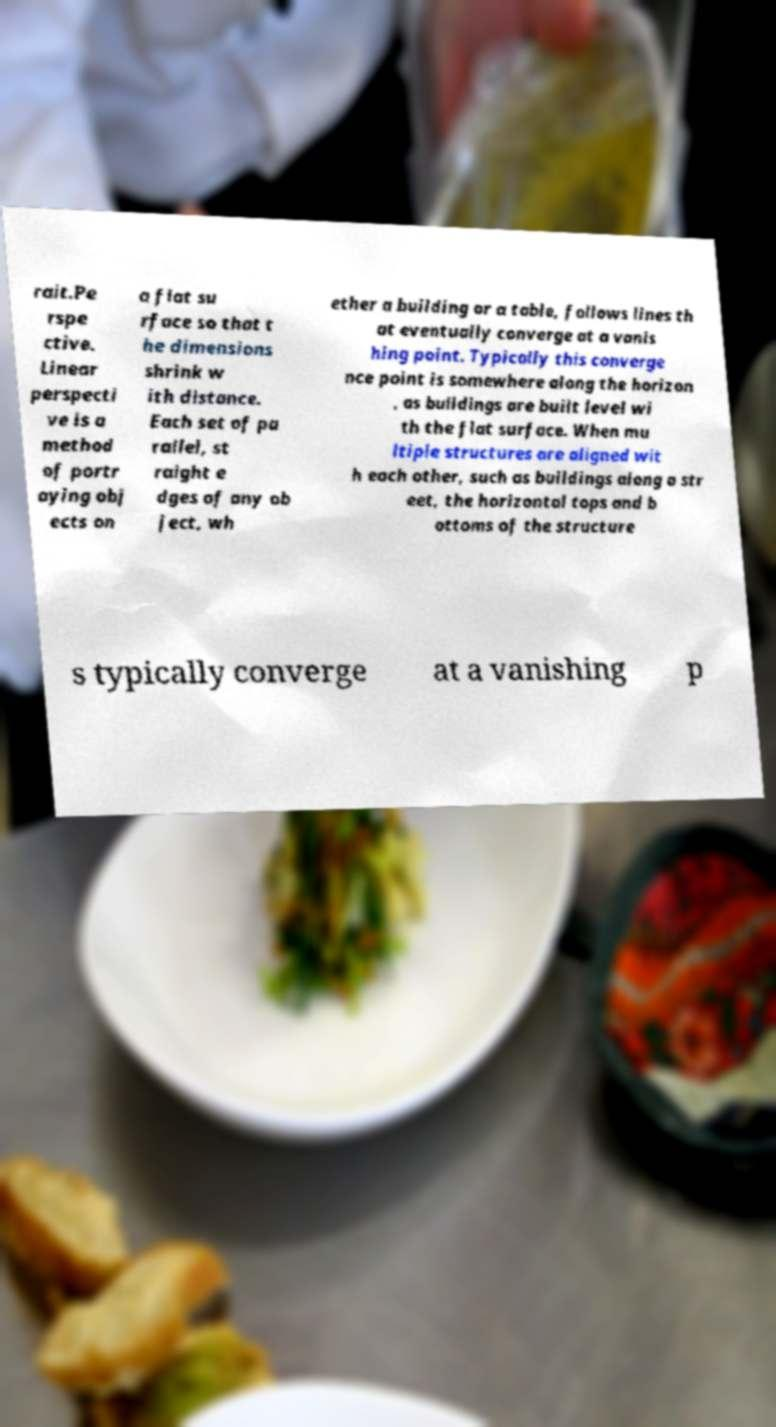Please identify and transcribe the text found in this image. rait.Pe rspe ctive. Linear perspecti ve is a method of portr aying obj ects on a flat su rface so that t he dimensions shrink w ith distance. Each set of pa rallel, st raight e dges of any ob ject, wh ether a building or a table, follows lines th at eventually converge at a vanis hing point. Typically this converge nce point is somewhere along the horizon , as buildings are built level wi th the flat surface. When mu ltiple structures are aligned wit h each other, such as buildings along a str eet, the horizontal tops and b ottoms of the structure s typically converge at a vanishing p 